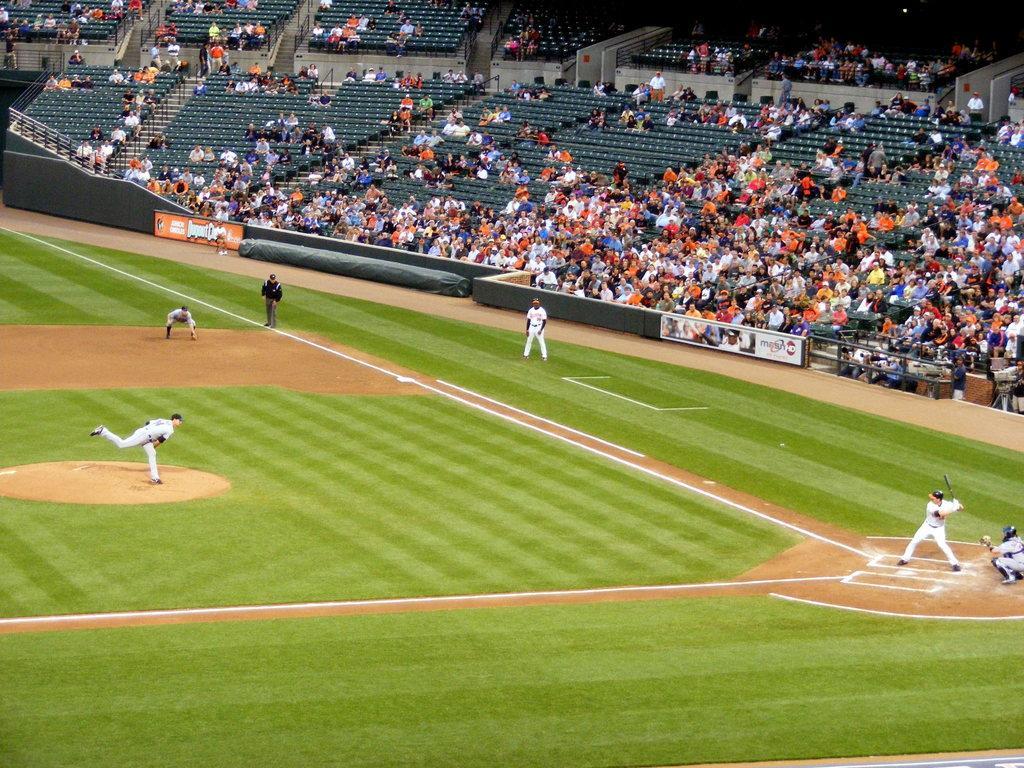How would you summarize this image in a sentence or two? There are some people playing baseball. On the ground there is grass lawn. In the back there are many people sitting on the stadium. Also there are banners. 